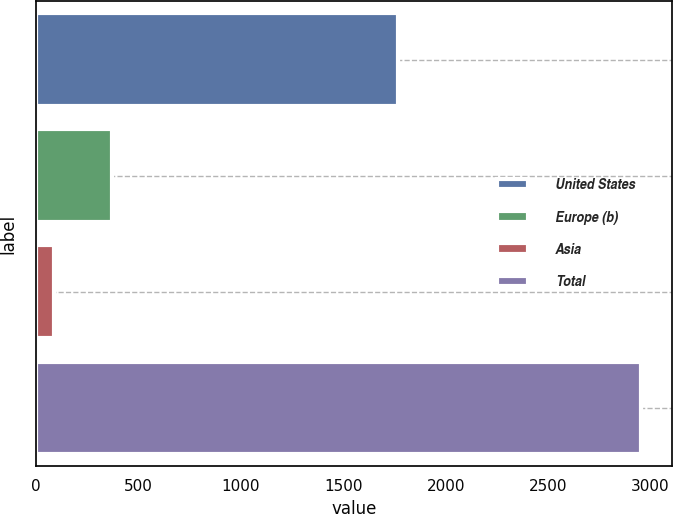<chart> <loc_0><loc_0><loc_500><loc_500><bar_chart><fcel>United States<fcel>Europe (b)<fcel>Asia<fcel>Total<nl><fcel>1767<fcel>373<fcel>86<fcel>2956<nl></chart> 